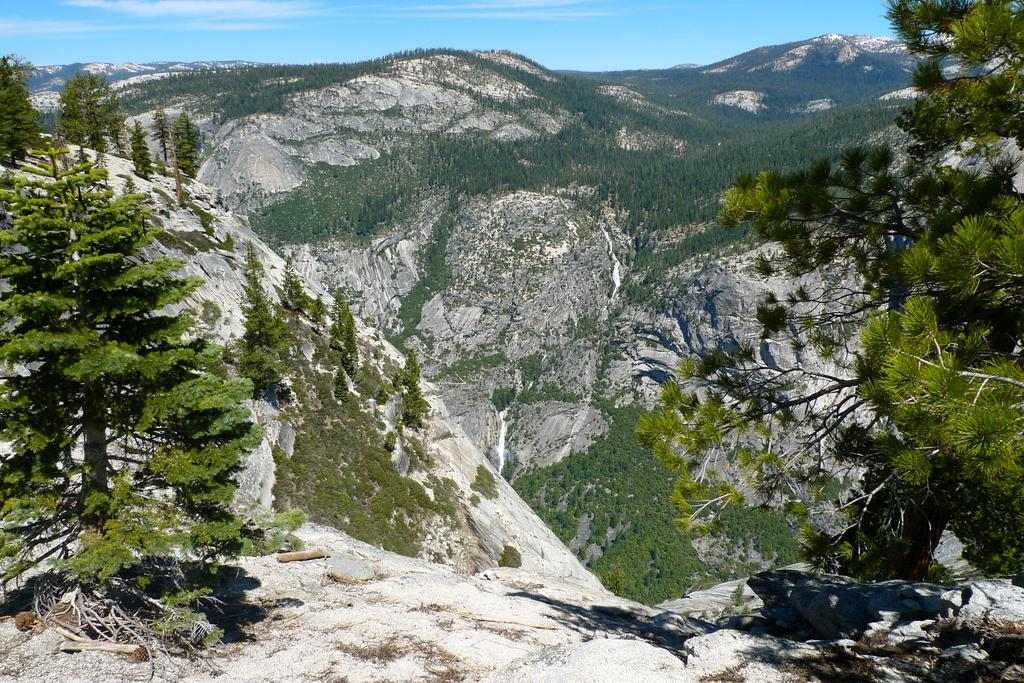What type of vegetation can be seen in the image? There are trees in the image. What type of geographical feature is visible in the image? There are mountains in the image. What part of the natural environment is visible in the image? The sky is visible in the image. What book is the person reading in the image? There is no person or book present in the image; it features trees, mountains, and the sky. What type of bell can be seen in the image? There is no bell present in the image. 